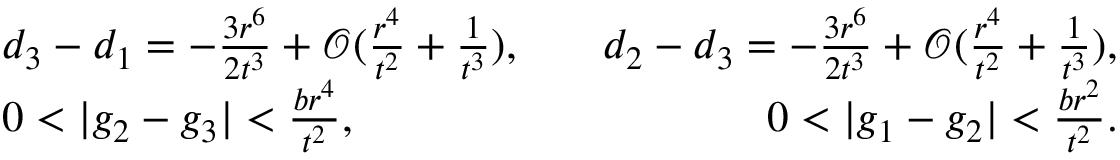Convert formula to latex. <formula><loc_0><loc_0><loc_500><loc_500>\begin{array} { r l r } & { d _ { 3 } - d _ { 1 } = - \frac { 3 r ^ { 6 } } { 2 t ^ { 3 } } + \mathcal { O } ( \frac { r ^ { 4 } } { t ^ { 2 } } + \frac { 1 } { t ^ { 3 } } ) , \quad } & { d _ { 2 } - d _ { 3 } = - \frac { 3 r ^ { 6 } } { 2 t ^ { 3 } } + \mathcal { O } ( \frac { r ^ { 4 } } { t ^ { 2 } } + \frac { 1 } { t ^ { 3 } } ) , } \\ & { 0 < | g _ { 2 } - g _ { 3 } | < \frac { b r ^ { 4 } } { t ^ { 2 } } , \quad } & { 0 < | g _ { 1 } - g _ { 2 } | < \frac { b r ^ { 2 } } { t ^ { 2 } } . } \end{array}</formula> 